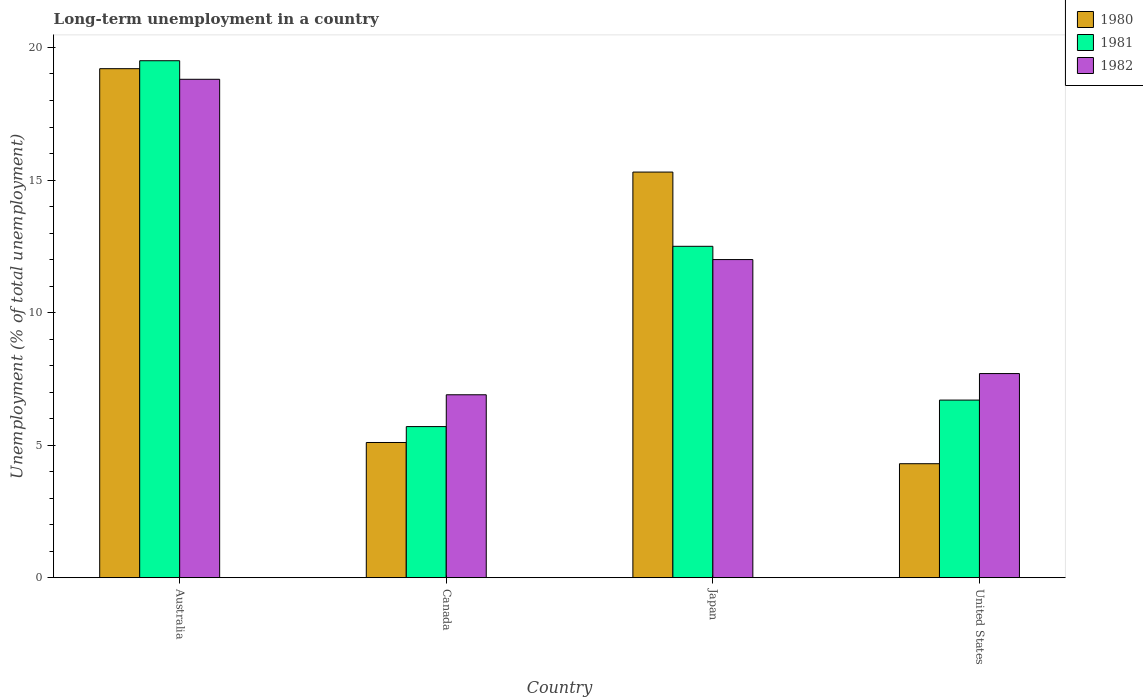Are the number of bars per tick equal to the number of legend labels?
Offer a very short reply. Yes. Are the number of bars on each tick of the X-axis equal?
Your answer should be compact. Yes. How many bars are there on the 4th tick from the left?
Your answer should be very brief. 3. What is the percentage of long-term unemployed population in 1981 in Canada?
Provide a succinct answer. 5.7. Across all countries, what is the maximum percentage of long-term unemployed population in 1982?
Offer a very short reply. 18.8. Across all countries, what is the minimum percentage of long-term unemployed population in 1982?
Provide a short and direct response. 6.9. What is the total percentage of long-term unemployed population in 1981 in the graph?
Keep it short and to the point. 44.4. What is the difference between the percentage of long-term unemployed population in 1981 in Canada and that in Japan?
Your answer should be very brief. -6.8. What is the difference between the percentage of long-term unemployed population in 1982 in Japan and the percentage of long-term unemployed population in 1981 in Canada?
Ensure brevity in your answer.  6.3. What is the average percentage of long-term unemployed population in 1981 per country?
Keep it short and to the point. 11.1. What is the difference between the percentage of long-term unemployed population of/in 1980 and percentage of long-term unemployed population of/in 1982 in Japan?
Make the answer very short. 3.3. In how many countries, is the percentage of long-term unemployed population in 1982 greater than 11 %?
Offer a terse response. 2. What is the ratio of the percentage of long-term unemployed population in 1982 in Japan to that in United States?
Provide a short and direct response. 1.56. What is the difference between the highest and the second highest percentage of long-term unemployed population in 1981?
Provide a short and direct response. 7. What is the difference between the highest and the lowest percentage of long-term unemployed population in 1982?
Offer a terse response. 11.9. In how many countries, is the percentage of long-term unemployed population in 1982 greater than the average percentage of long-term unemployed population in 1982 taken over all countries?
Your answer should be very brief. 2. Is the sum of the percentage of long-term unemployed population in 1981 in Japan and United States greater than the maximum percentage of long-term unemployed population in 1982 across all countries?
Keep it short and to the point. Yes. What does the 1st bar from the left in Australia represents?
Keep it short and to the point. 1980. How many countries are there in the graph?
Your response must be concise. 4. Are the values on the major ticks of Y-axis written in scientific E-notation?
Your answer should be compact. No. Does the graph contain any zero values?
Offer a terse response. No. Does the graph contain grids?
Ensure brevity in your answer.  No. How are the legend labels stacked?
Offer a very short reply. Vertical. What is the title of the graph?
Keep it short and to the point. Long-term unemployment in a country. What is the label or title of the X-axis?
Provide a succinct answer. Country. What is the label or title of the Y-axis?
Ensure brevity in your answer.  Unemployment (% of total unemployment). What is the Unemployment (% of total unemployment) in 1980 in Australia?
Provide a succinct answer. 19.2. What is the Unemployment (% of total unemployment) of 1981 in Australia?
Give a very brief answer. 19.5. What is the Unemployment (% of total unemployment) in 1982 in Australia?
Provide a short and direct response. 18.8. What is the Unemployment (% of total unemployment) in 1980 in Canada?
Offer a very short reply. 5.1. What is the Unemployment (% of total unemployment) in 1981 in Canada?
Give a very brief answer. 5.7. What is the Unemployment (% of total unemployment) in 1982 in Canada?
Make the answer very short. 6.9. What is the Unemployment (% of total unemployment) in 1980 in Japan?
Provide a short and direct response. 15.3. What is the Unemployment (% of total unemployment) in 1980 in United States?
Keep it short and to the point. 4.3. What is the Unemployment (% of total unemployment) of 1981 in United States?
Your response must be concise. 6.7. What is the Unemployment (% of total unemployment) in 1982 in United States?
Offer a very short reply. 7.7. Across all countries, what is the maximum Unemployment (% of total unemployment) of 1980?
Keep it short and to the point. 19.2. Across all countries, what is the maximum Unemployment (% of total unemployment) of 1982?
Keep it short and to the point. 18.8. Across all countries, what is the minimum Unemployment (% of total unemployment) of 1980?
Give a very brief answer. 4.3. Across all countries, what is the minimum Unemployment (% of total unemployment) in 1981?
Your response must be concise. 5.7. Across all countries, what is the minimum Unemployment (% of total unemployment) in 1982?
Offer a very short reply. 6.9. What is the total Unemployment (% of total unemployment) of 1980 in the graph?
Give a very brief answer. 43.9. What is the total Unemployment (% of total unemployment) of 1981 in the graph?
Your answer should be very brief. 44.4. What is the total Unemployment (% of total unemployment) of 1982 in the graph?
Give a very brief answer. 45.4. What is the difference between the Unemployment (% of total unemployment) of 1980 in Australia and that in Canada?
Give a very brief answer. 14.1. What is the difference between the Unemployment (% of total unemployment) of 1981 in Australia and that in Canada?
Your answer should be compact. 13.8. What is the difference between the Unemployment (% of total unemployment) in 1982 in Australia and that in Japan?
Provide a short and direct response. 6.8. What is the difference between the Unemployment (% of total unemployment) in 1981 in Australia and that in United States?
Your answer should be compact. 12.8. What is the difference between the Unemployment (% of total unemployment) of 1982 in Australia and that in United States?
Your response must be concise. 11.1. What is the difference between the Unemployment (% of total unemployment) of 1980 in Canada and that in Japan?
Give a very brief answer. -10.2. What is the difference between the Unemployment (% of total unemployment) of 1981 in Canada and that in Japan?
Offer a very short reply. -6.8. What is the difference between the Unemployment (% of total unemployment) in 1982 in Canada and that in Japan?
Give a very brief answer. -5.1. What is the difference between the Unemployment (% of total unemployment) in 1981 in Japan and that in United States?
Offer a very short reply. 5.8. What is the difference between the Unemployment (% of total unemployment) in 1982 in Japan and that in United States?
Keep it short and to the point. 4.3. What is the difference between the Unemployment (% of total unemployment) in 1981 in Australia and the Unemployment (% of total unemployment) in 1982 in Canada?
Offer a terse response. 12.6. What is the difference between the Unemployment (% of total unemployment) of 1980 in Australia and the Unemployment (% of total unemployment) of 1981 in Japan?
Offer a terse response. 6.7. What is the difference between the Unemployment (% of total unemployment) in 1980 in Australia and the Unemployment (% of total unemployment) in 1981 in United States?
Offer a terse response. 12.5. What is the difference between the Unemployment (% of total unemployment) in 1980 in Canada and the Unemployment (% of total unemployment) in 1981 in Japan?
Keep it short and to the point. -7.4. What is the difference between the Unemployment (% of total unemployment) in 1980 in Canada and the Unemployment (% of total unemployment) in 1982 in Japan?
Offer a very short reply. -6.9. What is the difference between the Unemployment (% of total unemployment) in 1980 in Canada and the Unemployment (% of total unemployment) in 1982 in United States?
Make the answer very short. -2.6. What is the difference between the Unemployment (% of total unemployment) of 1980 in Japan and the Unemployment (% of total unemployment) of 1981 in United States?
Your answer should be compact. 8.6. What is the average Unemployment (% of total unemployment) in 1980 per country?
Provide a succinct answer. 10.97. What is the average Unemployment (% of total unemployment) of 1982 per country?
Your response must be concise. 11.35. What is the difference between the Unemployment (% of total unemployment) of 1980 and Unemployment (% of total unemployment) of 1982 in Australia?
Your response must be concise. 0.4. What is the difference between the Unemployment (% of total unemployment) in 1980 and Unemployment (% of total unemployment) in 1981 in Canada?
Keep it short and to the point. -0.6. What is the difference between the Unemployment (% of total unemployment) in 1980 and Unemployment (% of total unemployment) in 1982 in Japan?
Ensure brevity in your answer.  3.3. What is the difference between the Unemployment (% of total unemployment) in 1981 and Unemployment (% of total unemployment) in 1982 in Japan?
Provide a short and direct response. 0.5. What is the ratio of the Unemployment (% of total unemployment) of 1980 in Australia to that in Canada?
Give a very brief answer. 3.76. What is the ratio of the Unemployment (% of total unemployment) in 1981 in Australia to that in Canada?
Offer a very short reply. 3.42. What is the ratio of the Unemployment (% of total unemployment) in 1982 in Australia to that in Canada?
Make the answer very short. 2.72. What is the ratio of the Unemployment (% of total unemployment) in 1980 in Australia to that in Japan?
Keep it short and to the point. 1.25. What is the ratio of the Unemployment (% of total unemployment) in 1981 in Australia to that in Japan?
Make the answer very short. 1.56. What is the ratio of the Unemployment (% of total unemployment) of 1982 in Australia to that in Japan?
Provide a short and direct response. 1.57. What is the ratio of the Unemployment (% of total unemployment) of 1980 in Australia to that in United States?
Provide a short and direct response. 4.47. What is the ratio of the Unemployment (% of total unemployment) in 1981 in Australia to that in United States?
Offer a very short reply. 2.91. What is the ratio of the Unemployment (% of total unemployment) of 1982 in Australia to that in United States?
Ensure brevity in your answer.  2.44. What is the ratio of the Unemployment (% of total unemployment) in 1980 in Canada to that in Japan?
Your answer should be very brief. 0.33. What is the ratio of the Unemployment (% of total unemployment) of 1981 in Canada to that in Japan?
Offer a terse response. 0.46. What is the ratio of the Unemployment (% of total unemployment) of 1982 in Canada to that in Japan?
Provide a short and direct response. 0.57. What is the ratio of the Unemployment (% of total unemployment) of 1980 in Canada to that in United States?
Your response must be concise. 1.19. What is the ratio of the Unemployment (% of total unemployment) in 1981 in Canada to that in United States?
Provide a short and direct response. 0.85. What is the ratio of the Unemployment (% of total unemployment) of 1982 in Canada to that in United States?
Provide a succinct answer. 0.9. What is the ratio of the Unemployment (% of total unemployment) of 1980 in Japan to that in United States?
Provide a succinct answer. 3.56. What is the ratio of the Unemployment (% of total unemployment) in 1981 in Japan to that in United States?
Your answer should be very brief. 1.87. What is the ratio of the Unemployment (% of total unemployment) of 1982 in Japan to that in United States?
Give a very brief answer. 1.56. What is the difference between the highest and the second highest Unemployment (% of total unemployment) in 1980?
Provide a succinct answer. 3.9. What is the difference between the highest and the second highest Unemployment (% of total unemployment) of 1981?
Offer a very short reply. 7. What is the difference between the highest and the second highest Unemployment (% of total unemployment) in 1982?
Your response must be concise. 6.8. What is the difference between the highest and the lowest Unemployment (% of total unemployment) in 1981?
Give a very brief answer. 13.8. 